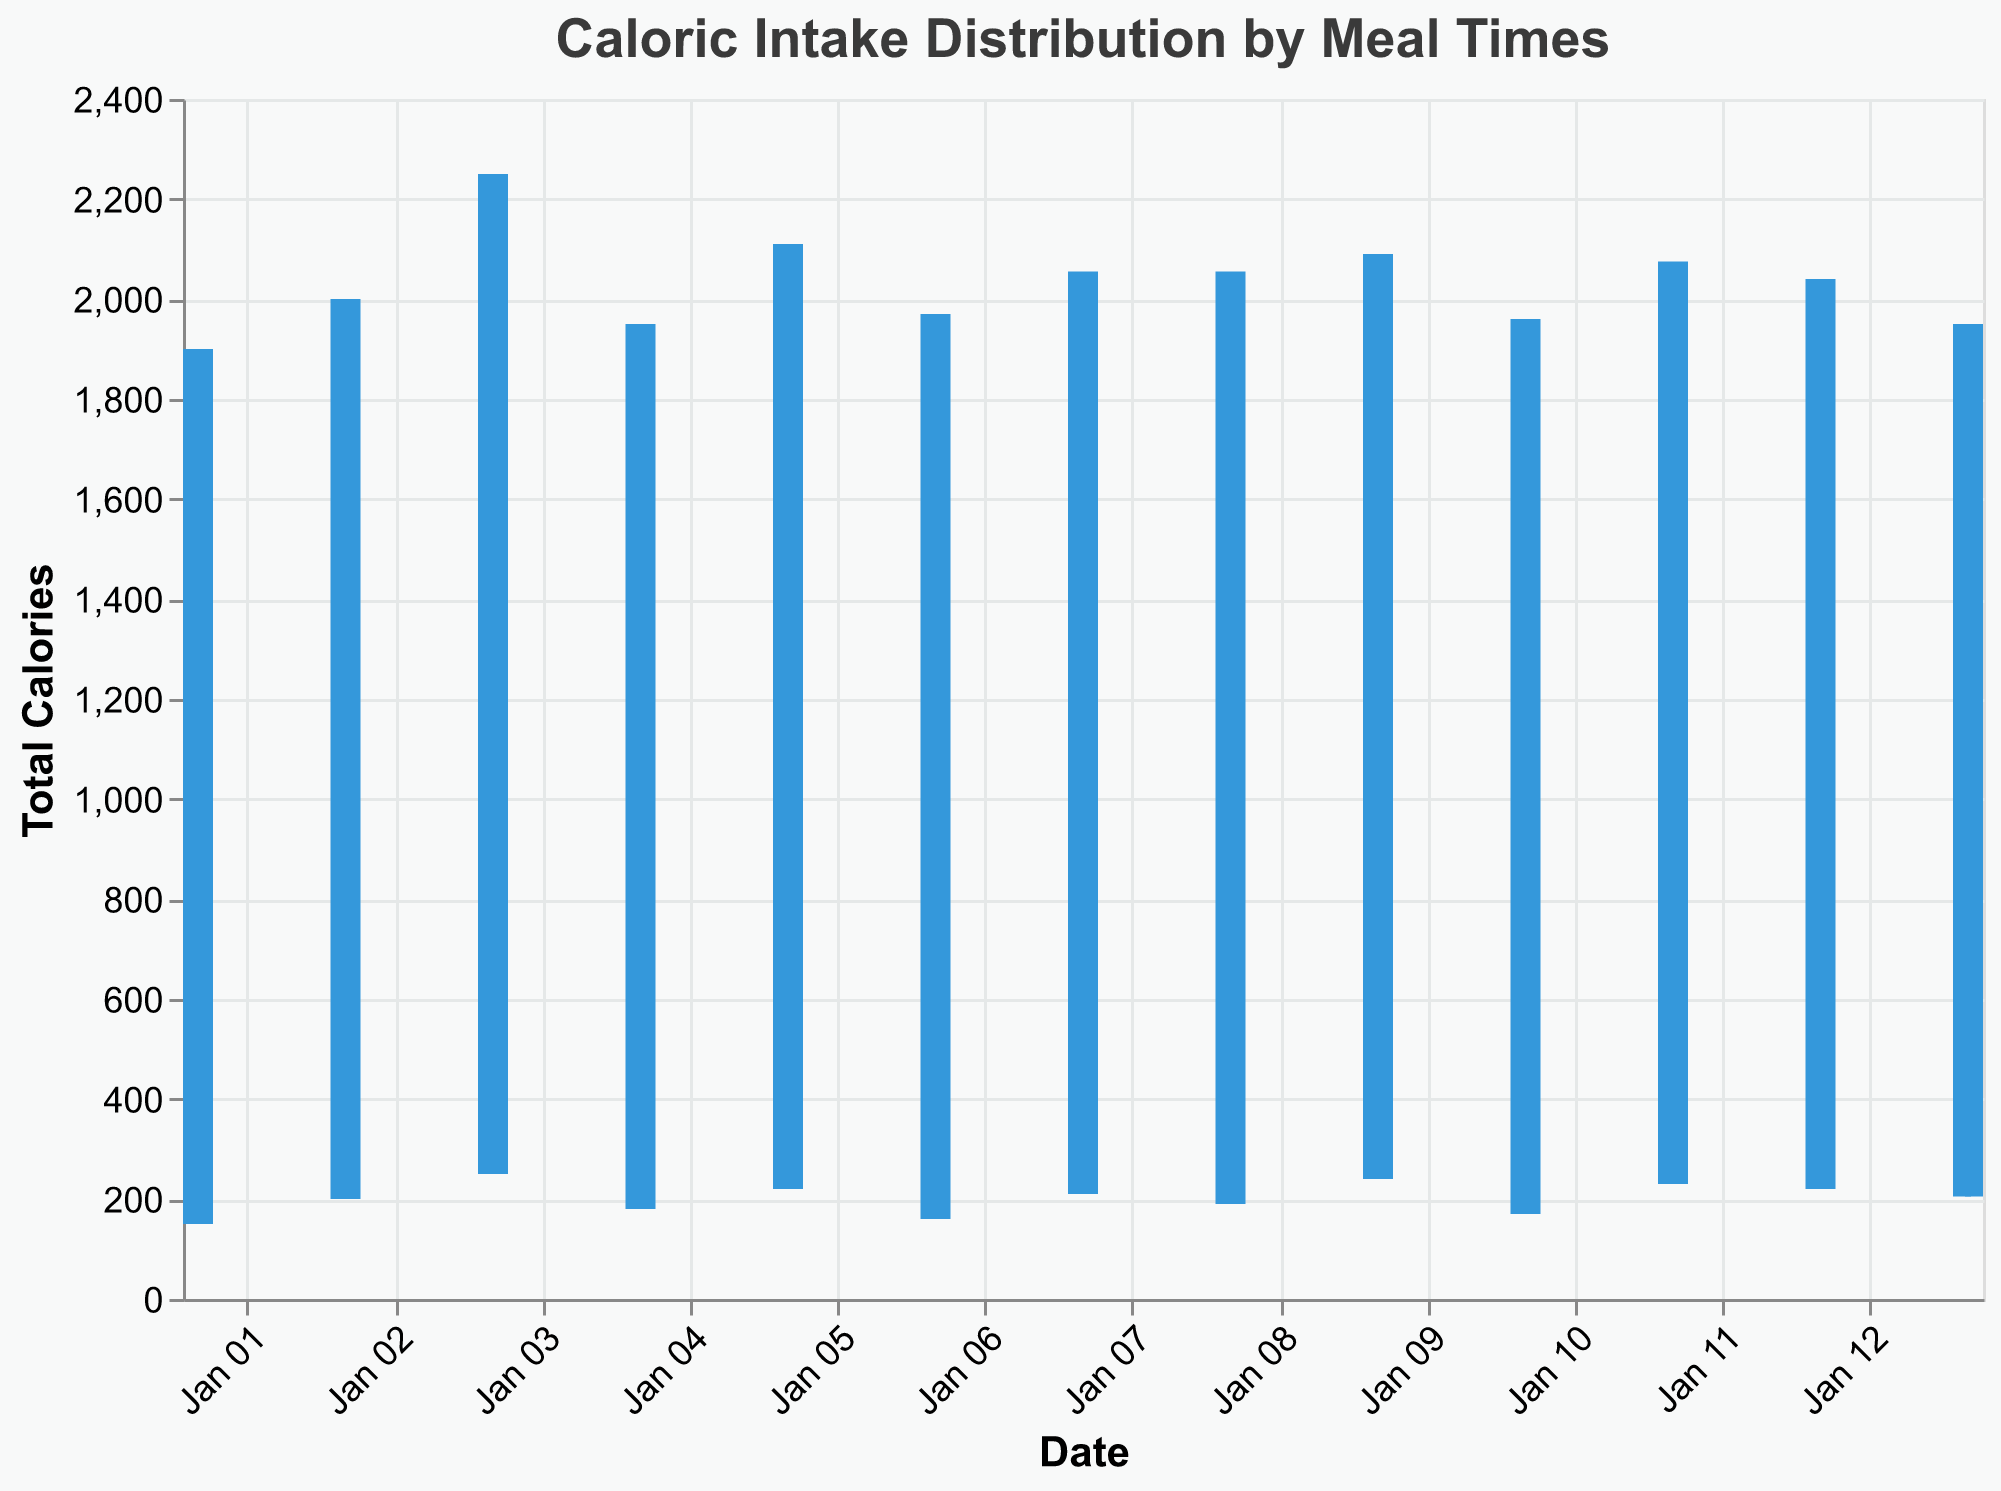What's the title of the figure? The title is displayed at the top of the plot and typically summarizes the main point of the figure. In this case, it reads "Caloric Intake Distribution by Meal Times"
Answer: Caloric Intake Distribution by Meal Times How many days of data are represented in the plot? The x-axis represents the dates, and by counting the number of unique dates, you can determine the number of days covered by the plot.
Answer: 13 What is the general trend of total caloric intake over the days displayed? Observing the y-axis, which represents the total calories, and considering the various days, the trend can be summed up. Overall, it appears to oscillate without a steady increase or decrease. Some days have higher total calories, and others lower.
Answer: Oscillates Which date had the highest total caloric intake? The plot shows the total caloric intake on the y-axis for each date. By identifying the highest point on the y-axis, you can find the date with the highest intake. The highest total caloric intake point reaches nearly 2250 calories, which is on January 3rd.
Answer: January 3 What's the range of calorie intake for January 3rd? The candlestick plot marks the high and low values for each date. For January 3rd, the high is at 900 and the low at 400 calories. So, the range is 900 - 400.
Answer: 500 On which date was the caloric intake distribution evenly spread across all meals? In a candlestick plot, if the low and high values are the same, it indicates an even distribution. The rule line will be short and uniform. It does not appear any date had an even spread as all displayed different highs and lows. Therefore, none of the days show this pattern.
Answer: None What is the highest caloric intake from any single meal during the period shown? The high point on each day's bar rule indicates the highest meal intake. Observing this peak, we see the highest value is on January 3rd with a caloric intake of 900.
Answer: 900 How does the caloric intake for January 5th compare with January 12th? First, identify the total caloric intake for these dates on the y-axis. January 5th shows a total of around 2110 calories, while January 12th shows around 2040 calories. Comparatively, January 5th has a slightly higher intake.
Answer: January 5th > January 12th Is there a date where caloric intake is significantly lower than other days? By looking at the y-axis values and identifying any significantly shorter bars, January 1st shows a lower caloric intake compared to other days, which is about 1900 calories.
Answer: January 1 How is the color used to differentiate single meal calorie intake points? Color differentiation is used to highlight whether the meal intake is consistently the same. Each date's color would be the standard blue unless all meals have the same calorie value, potentially showing different color coding. However, in this plot, all bars are consistently blue.
Answer: Consistent color What can you infer about your eating habits from the plot? Based on the oscillation in total caloric intake, one might infer that while there are certain days with high intake, others balance it out. None of the days show uniform intake across all meals, indicating variance in eating habits. This might help in planning more balanced caloric intake across the days.
Answer: Varying eating habits 